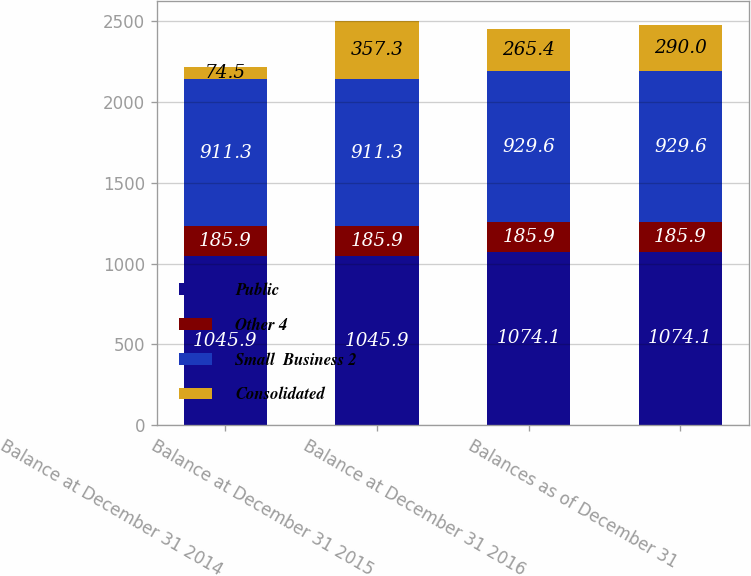<chart> <loc_0><loc_0><loc_500><loc_500><stacked_bar_chart><ecel><fcel>Balance at December 31 2014<fcel>Balance at December 31 2015<fcel>Balance at December 31 2016<fcel>Balances as of December 31<nl><fcel>Public<fcel>1045.9<fcel>1045.9<fcel>1074.1<fcel>1074.1<nl><fcel>Other 4<fcel>185.9<fcel>185.9<fcel>185.9<fcel>185.9<nl><fcel>Small  Business 2<fcel>911.3<fcel>911.3<fcel>929.6<fcel>929.6<nl><fcel>Consolidated<fcel>74.5<fcel>357.3<fcel>265.4<fcel>290<nl></chart> 